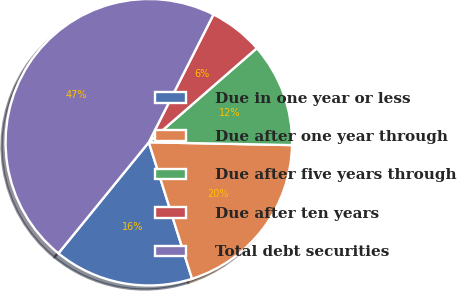<chart> <loc_0><loc_0><loc_500><loc_500><pie_chart><fcel>Due in one year or less<fcel>Due after one year through<fcel>Due after five years through<fcel>Due after ten years<fcel>Total debt securities<nl><fcel>15.76%<fcel>19.8%<fcel>11.72%<fcel>6.14%<fcel>46.58%<nl></chart> 